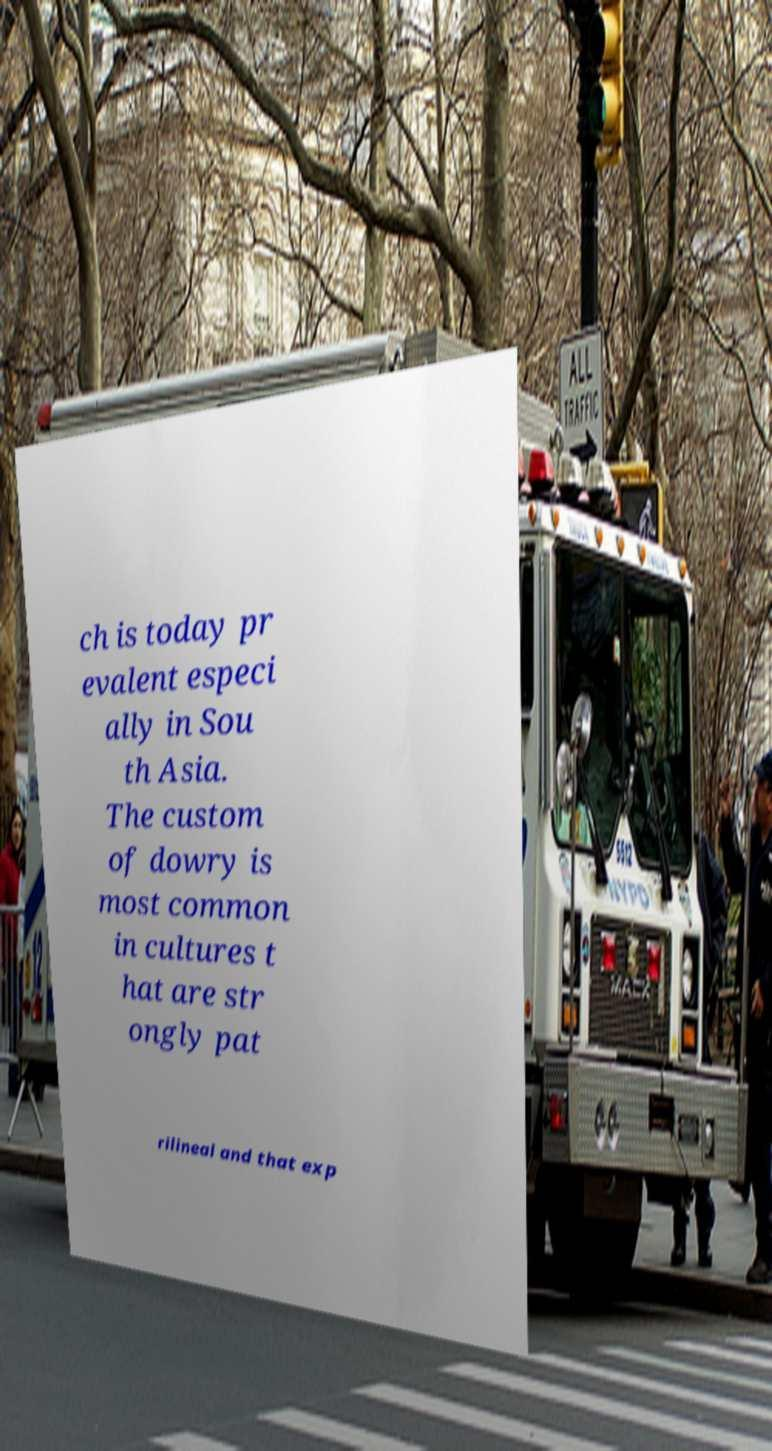Could you assist in decoding the text presented in this image and type it out clearly? ch is today pr evalent especi ally in Sou th Asia. The custom of dowry is most common in cultures t hat are str ongly pat rilineal and that exp 